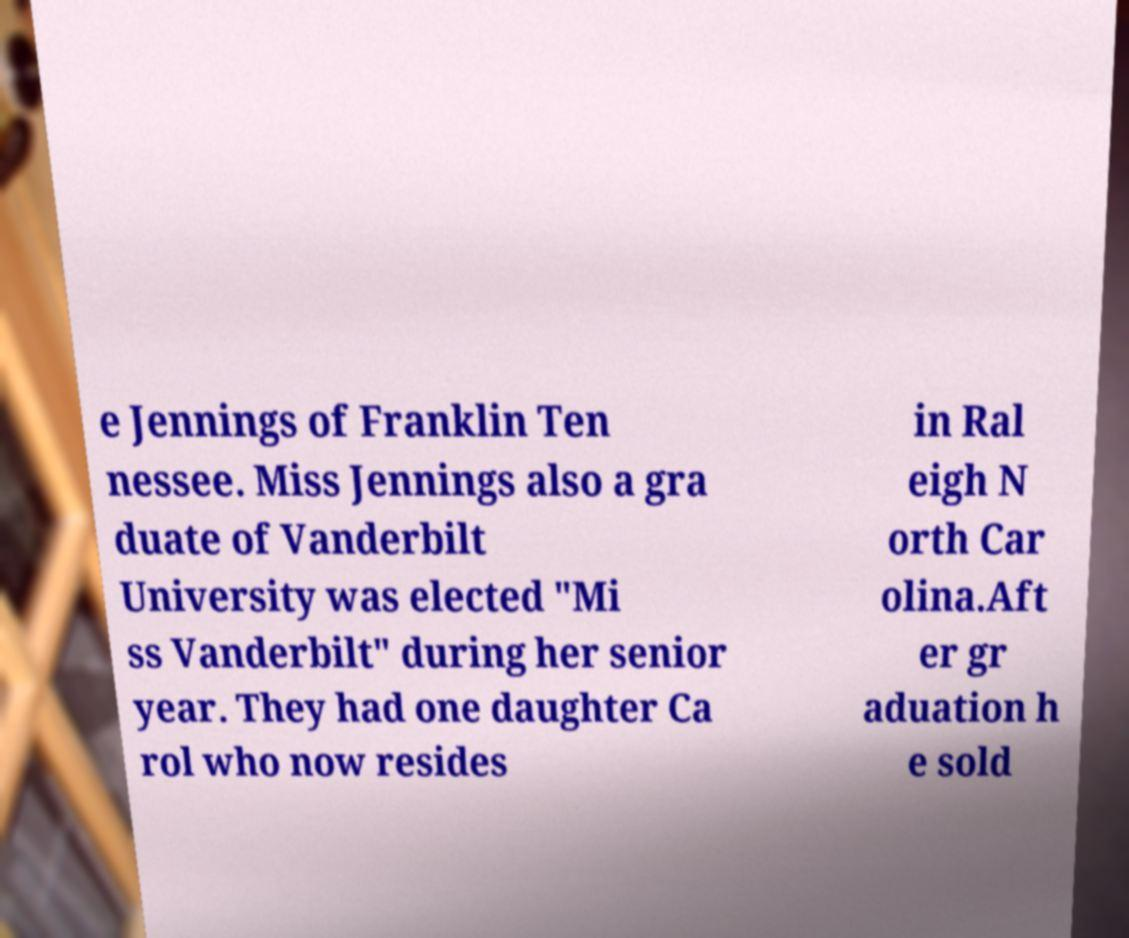Please identify and transcribe the text found in this image. e Jennings of Franklin Ten nessee. Miss Jennings also a gra duate of Vanderbilt University was elected "Mi ss Vanderbilt" during her senior year. They had one daughter Ca rol who now resides in Ral eigh N orth Car olina.Aft er gr aduation h e sold 